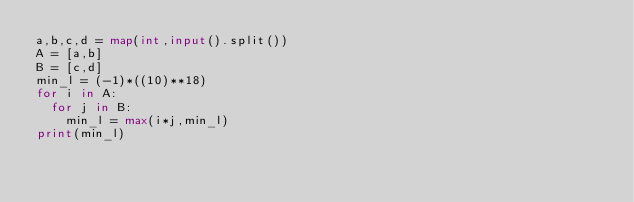Convert code to text. <code><loc_0><loc_0><loc_500><loc_500><_Python_>a,b,c,d = map(int,input().split())
A = [a,b]
B = [c,d]
min_l = (-1)*((10)**18)
for i in A:
  for j in B:
    min_l = max(i*j,min_l)
print(min_l)</code> 